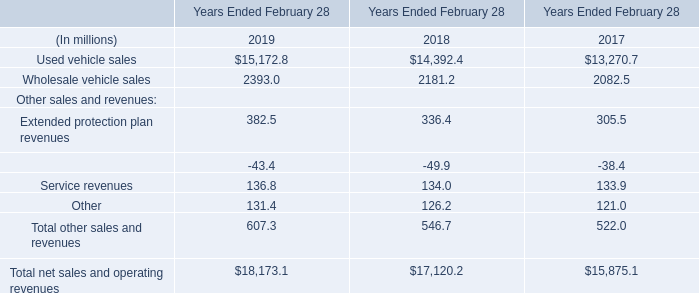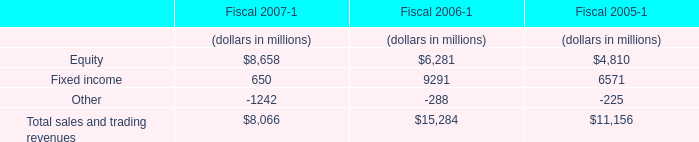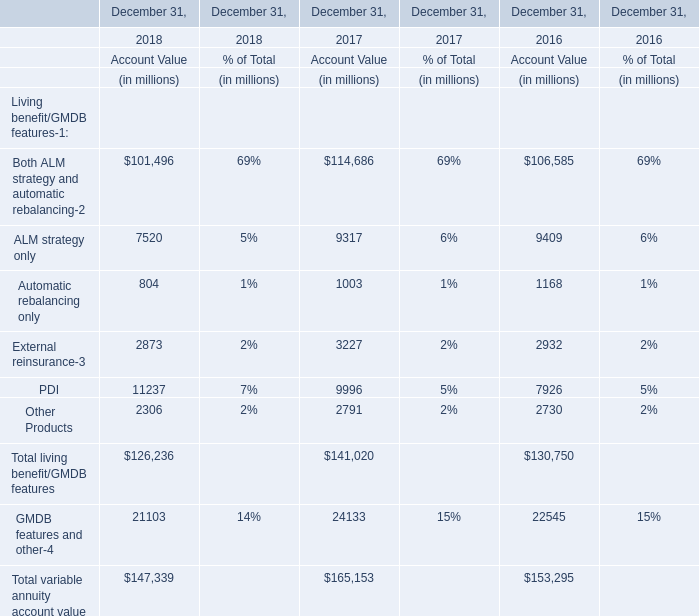The Account Value of Other Products on December 31 in which year ranks first? 
Answer: 2017. 